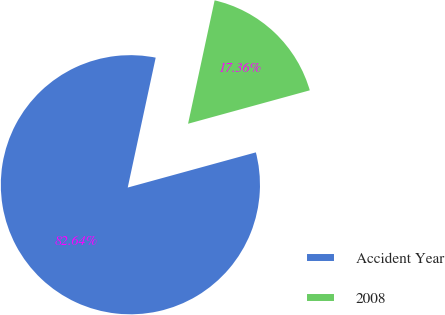<chart> <loc_0><loc_0><loc_500><loc_500><pie_chart><fcel>Accident Year<fcel>2008<nl><fcel>82.64%<fcel>17.36%<nl></chart> 